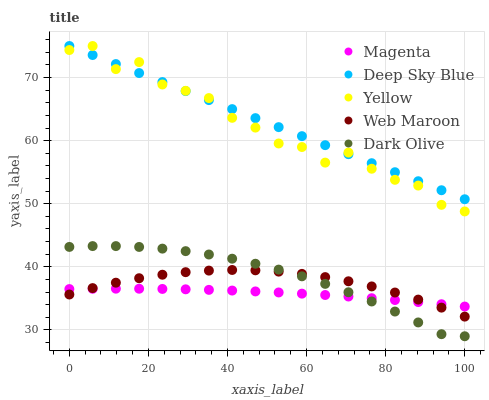Does Magenta have the minimum area under the curve?
Answer yes or no. Yes. Does Deep Sky Blue have the maximum area under the curve?
Answer yes or no. Yes. Does Dark Olive have the minimum area under the curve?
Answer yes or no. No. Does Dark Olive have the maximum area under the curve?
Answer yes or no. No. Is Deep Sky Blue the smoothest?
Answer yes or no. Yes. Is Yellow the roughest?
Answer yes or no. Yes. Is Dark Olive the smoothest?
Answer yes or no. No. Is Dark Olive the roughest?
Answer yes or no. No. Does Dark Olive have the lowest value?
Answer yes or no. Yes. Does Web Maroon have the lowest value?
Answer yes or no. No. Does Deep Sky Blue have the highest value?
Answer yes or no. Yes. Does Dark Olive have the highest value?
Answer yes or no. No. Is Dark Olive less than Yellow?
Answer yes or no. Yes. Is Yellow greater than Web Maroon?
Answer yes or no. Yes. Does Magenta intersect Web Maroon?
Answer yes or no. Yes. Is Magenta less than Web Maroon?
Answer yes or no. No. Is Magenta greater than Web Maroon?
Answer yes or no. No. Does Dark Olive intersect Yellow?
Answer yes or no. No. 